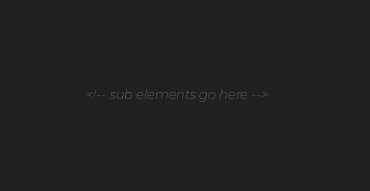<code> <loc_0><loc_0><loc_500><loc_500><_HTML_><!-- sub elements go here --></code> 